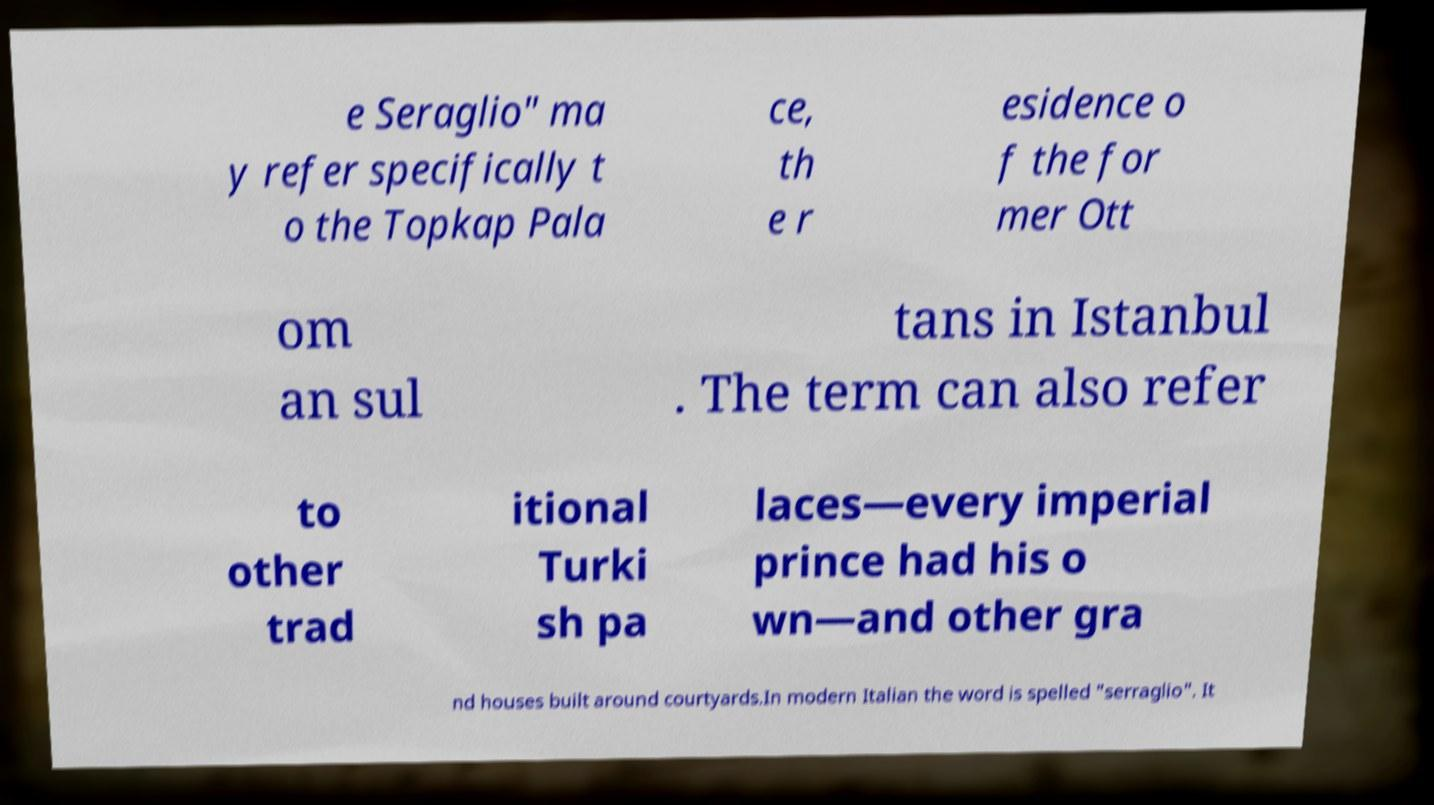There's text embedded in this image that I need extracted. Can you transcribe it verbatim? e Seraglio" ma y refer specifically t o the Topkap Pala ce, th e r esidence o f the for mer Ott om an sul tans in Istanbul . The term can also refer to other trad itional Turki sh pa laces—every imperial prince had his o wn—and other gra nd houses built around courtyards.In modern Italian the word is spelled "serraglio". It 